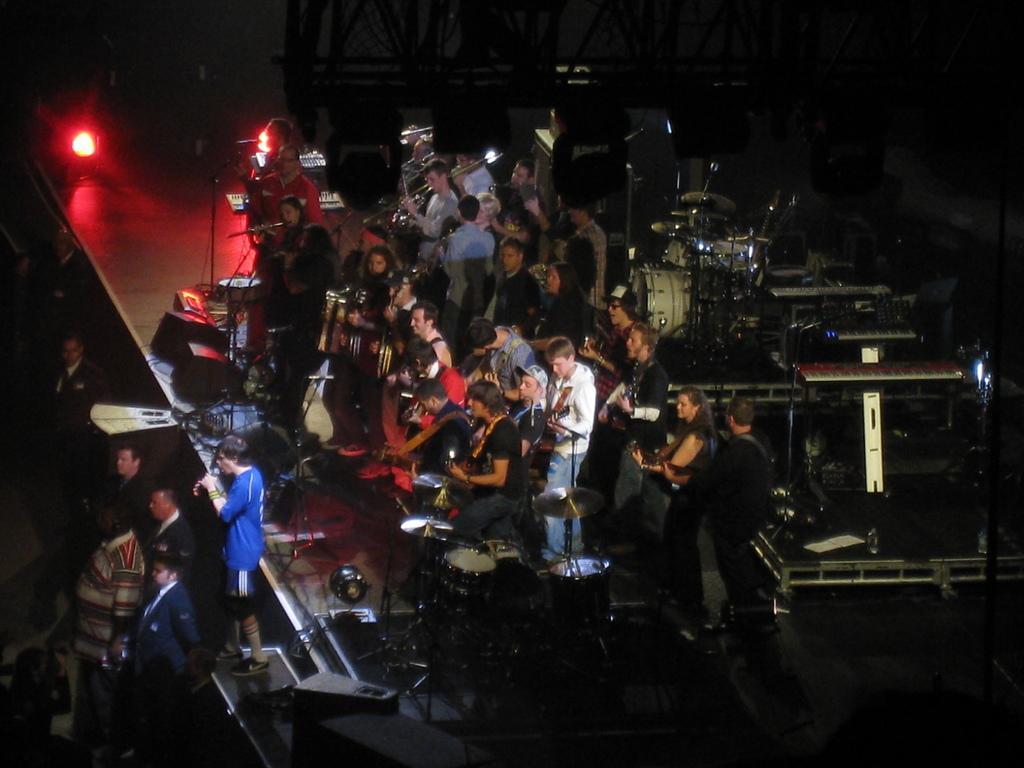In one or two sentences, can you explain what this image depicts? In the center of the image there are people playing musical instruments on the stage. In front of them there are few other people. Behind them there are musical instruments. On the left side of the image there are lights. In the background of the image there are metal rods. 